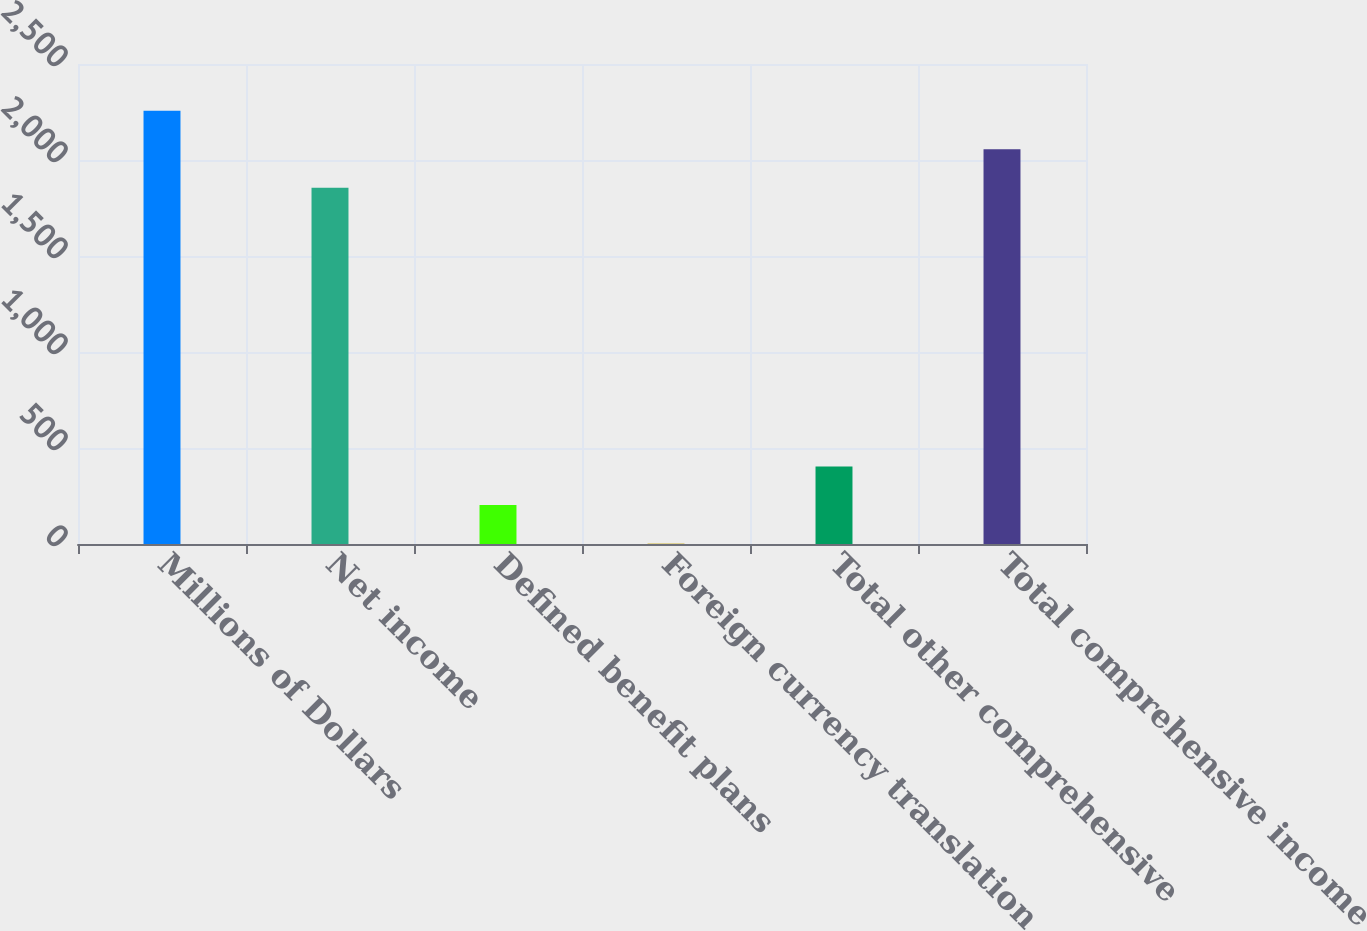<chart> <loc_0><loc_0><loc_500><loc_500><bar_chart><fcel>Millions of Dollars<fcel>Net income<fcel>Defined benefit plans<fcel>Foreign currency translation<fcel>Total other comprehensive<fcel>Total comprehensive income<nl><fcel>2256<fcel>1855<fcel>202.5<fcel>2<fcel>403<fcel>2055.5<nl></chart> 